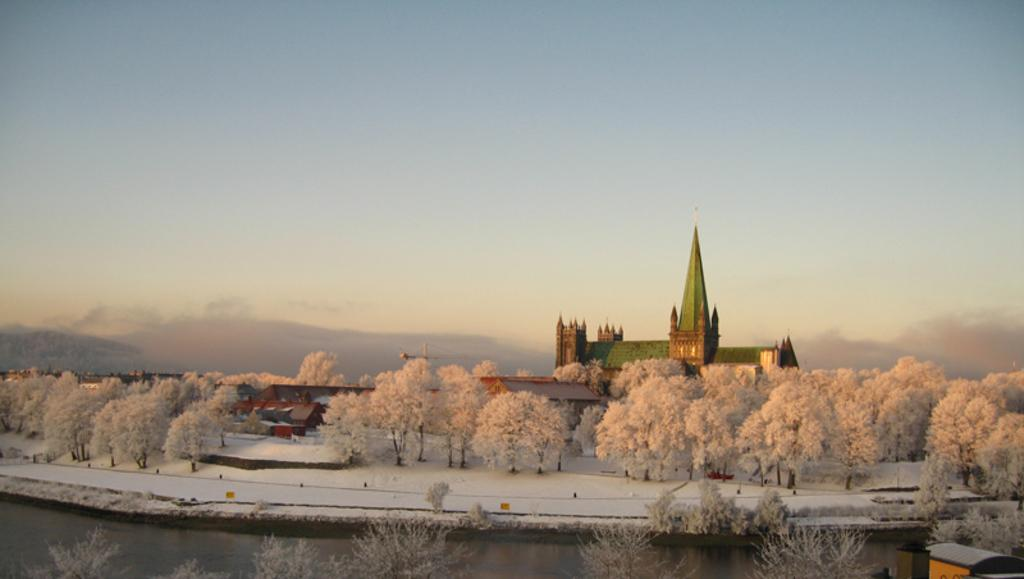What is one of the natural elements present in the image? There is water in the image. What is another natural element present in the image? There is snow in the image. What type of vegetation can be seen in the image? There are trees in the image. What type of structures are visible in the image? There are houses in the image. What type of geographical feature can be seen in the image? There are hills in the image. What is visible in the background of the image? The sky is visible in the background of the image. How many eyes can be seen on the trees in the image? Trees do not have eyes, so this question cannot be answered based on the image. 